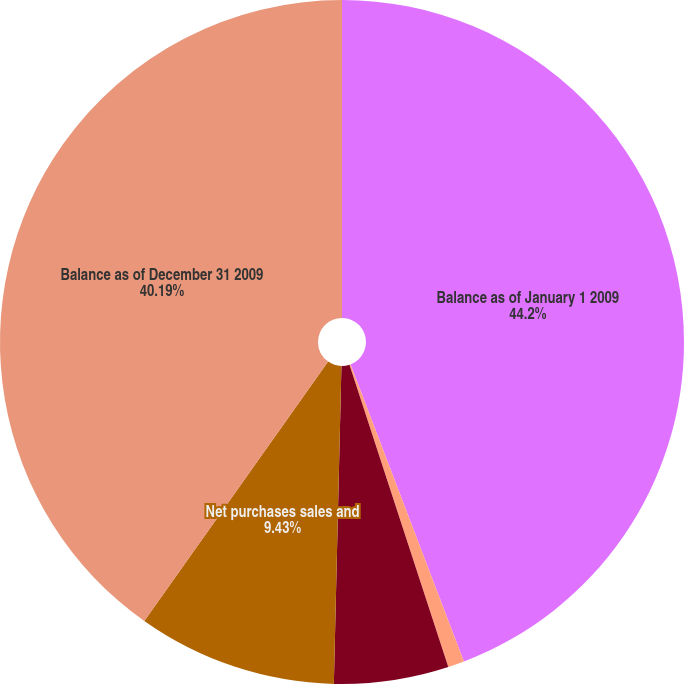Convert chart. <chart><loc_0><loc_0><loc_500><loc_500><pie_chart><fcel>Balance as of January 1 2009<fcel>Assets sold during the year<fcel>Assets still held at year end<fcel>Net purchases sales and<fcel>Balance as of December 31 2009<nl><fcel>44.2%<fcel>0.77%<fcel>5.41%<fcel>9.43%<fcel>40.19%<nl></chart> 